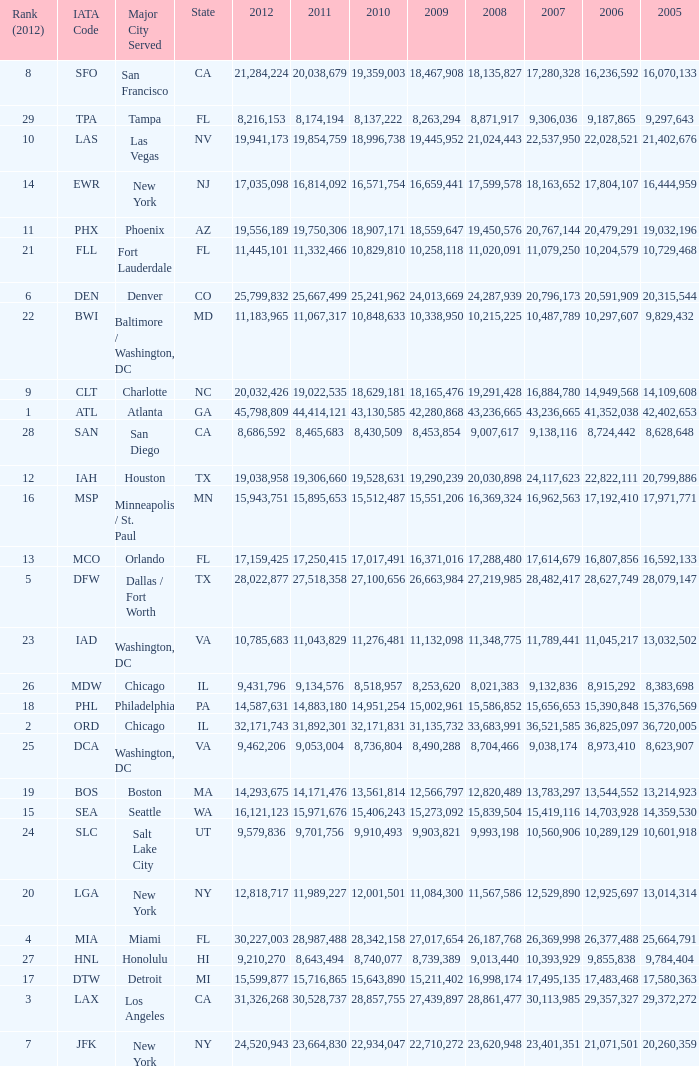For the IATA code of lax with 2009 less than 31,135,732 and 2011 less than 8,174,194, what is the sum of 2012? 0.0. 